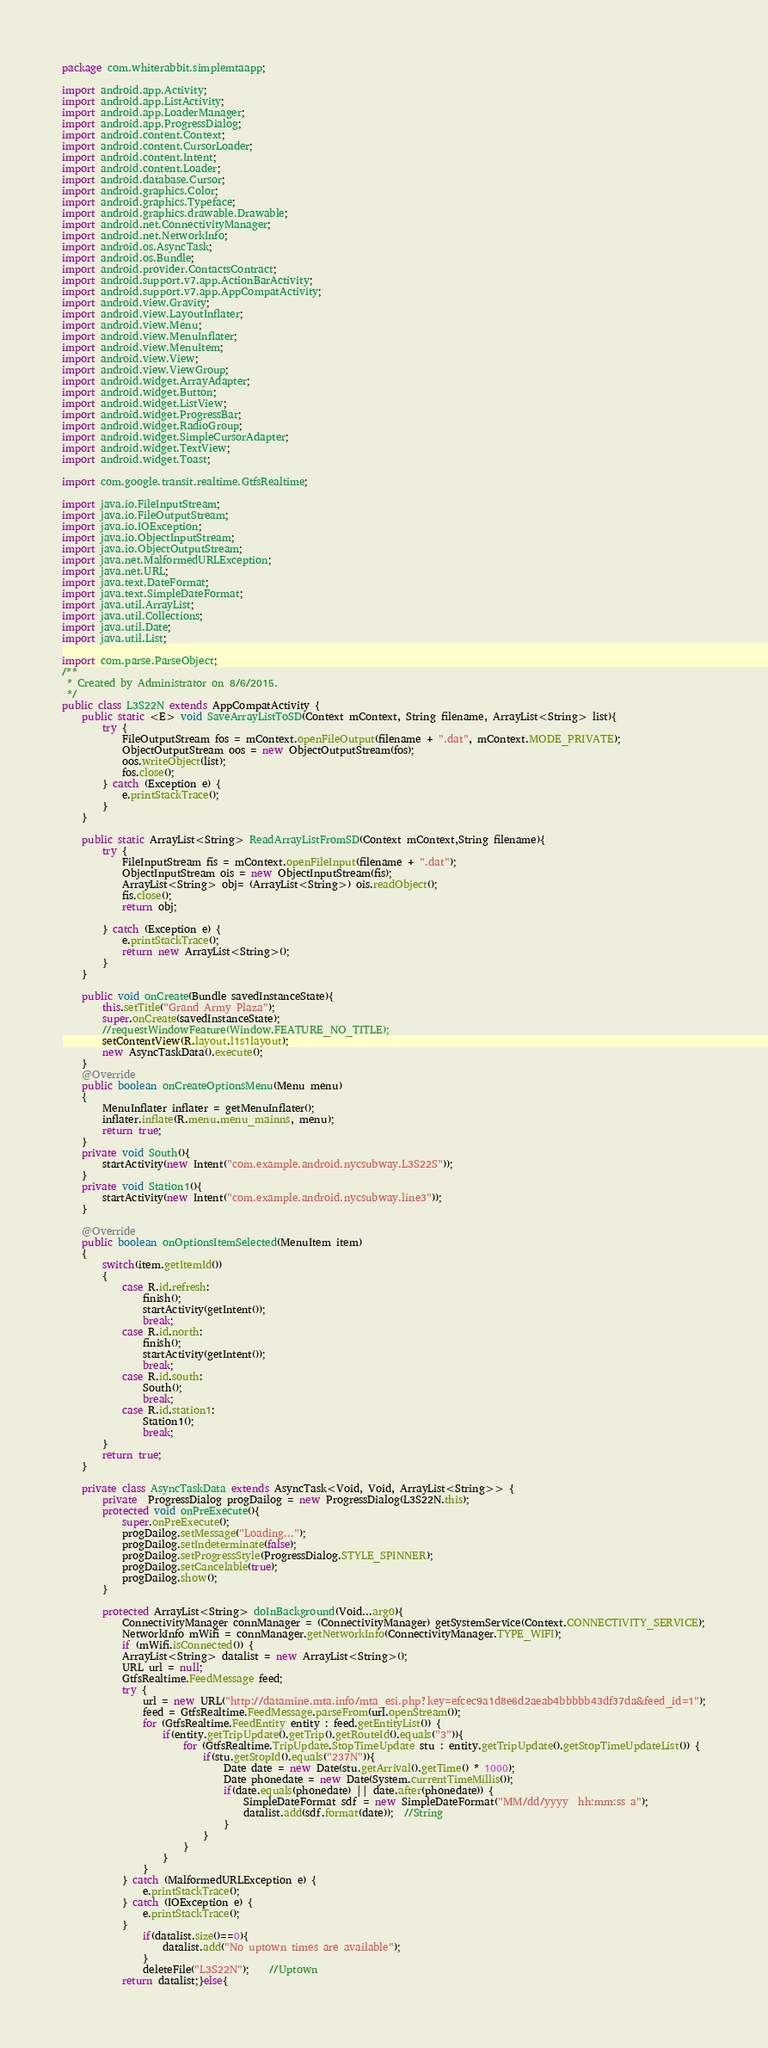Convert code to text. <code><loc_0><loc_0><loc_500><loc_500><_Java_>package com.whiterabbit.simplemtaapp;

import android.app.Activity;
import android.app.ListActivity;
import android.app.LoaderManager;
import android.app.ProgressDialog;
import android.content.Context;
import android.content.CursorLoader;
import android.content.Intent;
import android.content.Loader;
import android.database.Cursor;
import android.graphics.Color;
import android.graphics.Typeface;
import android.graphics.drawable.Drawable;
import android.net.ConnectivityManager;
import android.net.NetworkInfo;
import android.os.AsyncTask;
import android.os.Bundle;
import android.provider.ContactsContract;
import android.support.v7.app.ActionBarActivity;
import android.support.v7.app.AppCompatActivity;
import android.view.Gravity;
import android.view.LayoutInflater;
import android.view.Menu;
import android.view.MenuInflater;
import android.view.MenuItem;
import android.view.View;
import android.view.ViewGroup;
import android.widget.ArrayAdapter;
import android.widget.Button;
import android.widget.ListView;
import android.widget.ProgressBar;
import android.widget.RadioGroup;
import android.widget.SimpleCursorAdapter;
import android.widget.TextView;
import android.widget.Toast;

import com.google.transit.realtime.GtfsRealtime;

import java.io.FileInputStream;
import java.io.FileOutputStream;
import java.io.IOException;
import java.io.ObjectInputStream;
import java.io.ObjectOutputStream;
import java.net.MalformedURLException;
import java.net.URL;
import java.text.DateFormat;
import java.text.SimpleDateFormat;
import java.util.ArrayList;
import java.util.Collections;
import java.util.Date;
import java.util.List;

import com.parse.ParseObject;
/**
 * Created by Administrator on 8/6/2015.
 */
public class L3S22N extends AppCompatActivity {
    public static <E> void SaveArrayListToSD(Context mContext, String filename, ArrayList<String> list){
        try {
            FileOutputStream fos = mContext.openFileOutput(filename + ".dat", mContext.MODE_PRIVATE);
            ObjectOutputStream oos = new ObjectOutputStream(fos);
            oos.writeObject(list);
            fos.close();
        } catch (Exception e) {
            e.printStackTrace();
        }
    }

    public static ArrayList<String> ReadArrayListFromSD(Context mContext,String filename){
        try {
            FileInputStream fis = mContext.openFileInput(filename + ".dat");
            ObjectInputStream ois = new ObjectInputStream(fis);
            ArrayList<String> obj= (ArrayList<String>) ois.readObject();
            fis.close();
            return obj;

        } catch (Exception e) {
            e.printStackTrace();
            return new ArrayList<String>();
        }
    }

    public void onCreate(Bundle savedInstanceState){
        this.setTitle("Grand Army Plaza");
        super.onCreate(savedInstanceState);
        //requestWindowFeature(Window.FEATURE_NO_TITLE);
        setContentView(R.layout.l1s1layout);
        new AsyncTaskData().execute();
    }
    @Override
    public boolean onCreateOptionsMenu(Menu menu)
    {
        MenuInflater inflater = getMenuInflater();
        inflater.inflate(R.menu.menu_mainns, menu);
        return true;
    }
    private void South(){
        startActivity(new Intent("com.example.android.nycsubway.L3S22S"));
    }
    private void Station1(){
        startActivity(new Intent("com.example.android.nycsubway.line3"));
    }

    @Override
    public boolean onOptionsItemSelected(MenuItem item)
    {
        switch(item.getItemId())
        {
            case R.id.refresh:
                finish();
                startActivity(getIntent());
                break;
            case R.id.north:
                finish();
                startActivity(getIntent());
                break;
            case R.id.south:
                South();
                break;
            case R.id.station1:
                Station1();
                break;
        }
        return true;
    }

    private class AsyncTaskData extends AsyncTask<Void, Void, ArrayList<String>> {
        private  ProgressDialog progDailog = new ProgressDialog(L3S22N.this);
        protected void onPreExecute(){
            super.onPreExecute();
            progDailog.setMessage("Loading...");
            progDailog.setIndeterminate(false);
            progDailog.setProgressStyle(ProgressDialog.STYLE_SPINNER);
            progDailog.setCancelable(true);
            progDailog.show();
        }

        protected ArrayList<String> doInBackground(Void...arg0){
            ConnectivityManager connManager = (ConnectivityManager) getSystemService(Context.CONNECTIVITY_SERVICE);
            NetworkInfo mWifi = connManager.getNetworkInfo(ConnectivityManager.TYPE_WIFI);
            if (mWifi.isConnected()) {
            ArrayList<String> datalist = new ArrayList<String>();
            URL url = null;
            GtfsRealtime.FeedMessage feed;
            try {
                url = new URL("http://datamine.mta.info/mta_esi.php?key=efcec9a1d8e6d2aeab4bbbbb43df37da&feed_id=1");
                feed = GtfsRealtime.FeedMessage.parseFrom(url.openStream());
                for (GtfsRealtime.FeedEntity entity : feed.getEntityList()) {
                    if(entity.getTripUpdate().getTrip().getRouteId().equals("3")){
                        for (GtfsRealtime.TripUpdate.StopTimeUpdate stu : entity.getTripUpdate().getStopTimeUpdateList()) {
                            if(stu.getStopId().equals("237N")){
                                Date date = new Date(stu.getArrival().getTime() * 1000);
                                Date phonedate = new Date(System.currentTimeMillis());
                                if(date.equals(phonedate) || date.after(phonedate)) {
                                    SimpleDateFormat sdf = new SimpleDateFormat("MM/dd/yyyy  hh:mm:ss a");
                                    datalist.add(sdf.format(date));  //String
                                }
                            }
                        }
                    }
                }
            } catch (MalformedURLException e) {
                e.printStackTrace();
            } catch (IOException e) {
                e.printStackTrace();
            }
                if(datalist.size()==0){
                    datalist.add("No uptown times are available");
                }
                deleteFile("L3S22N");	//Uptown
            return datalist;}else{</code> 